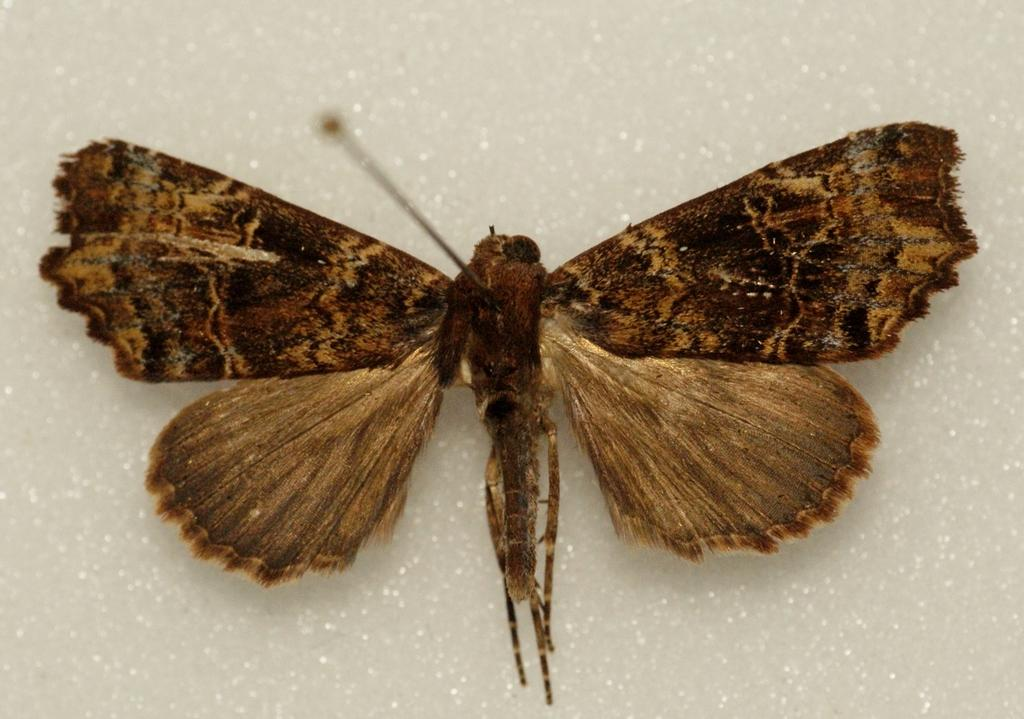What type of insect is in the image? There is a butterfly in the image. What colors can be seen on the butterfly? The butterfly has brown and black colors. What is the background or surface on which the butterfly is resting? The butterfly is on a white surface. What type of test is being conducted on the butterfly in the image? There is no test being conducted on the butterfly in the image; it is simply resting on a white surface. 